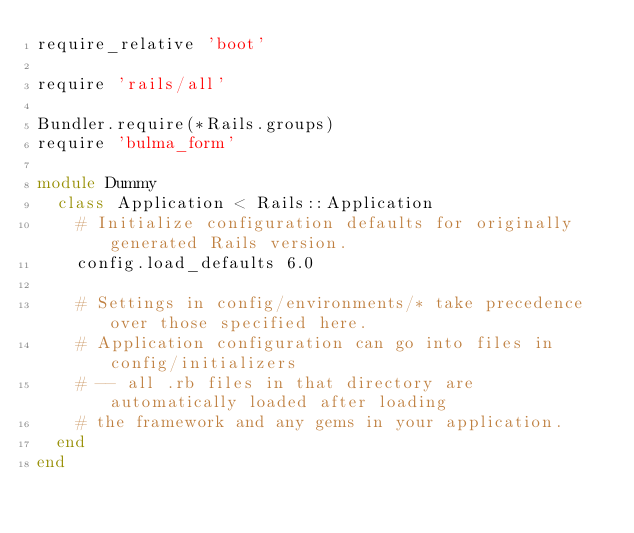Convert code to text. <code><loc_0><loc_0><loc_500><loc_500><_Ruby_>require_relative 'boot'

require 'rails/all'

Bundler.require(*Rails.groups)
require 'bulma_form'

module Dummy
  class Application < Rails::Application
    # Initialize configuration defaults for originally generated Rails version.
    config.load_defaults 6.0

    # Settings in config/environments/* take precedence over those specified here.
    # Application configuration can go into files in config/initializers
    # -- all .rb files in that directory are automatically loaded after loading
    # the framework and any gems in your application.
  end
end
</code> 